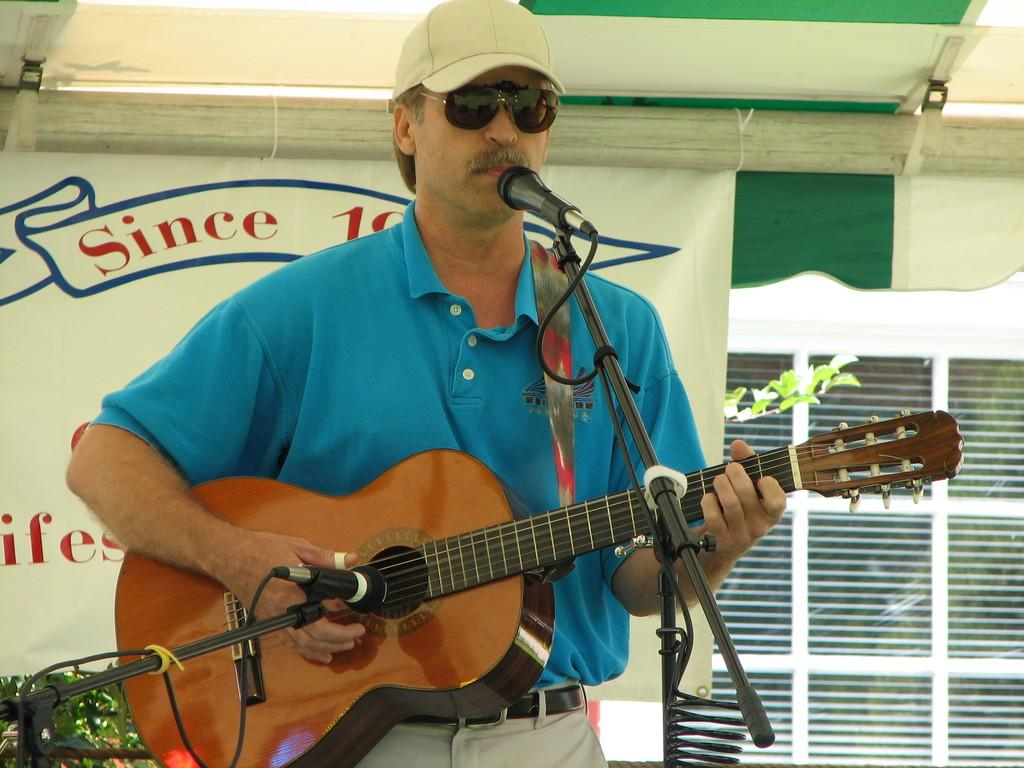What is the man in the image doing? There is a man standing in the image, but his activity is not specified. What musical instrument is present in the image? There is a guitar in the image. What device is used for amplifying sound in the image? There is a microphone in the image. What type of vegetation can be seen in the image? There are leaves in the image. What is hanging on the wall in the image? There is a poster in the image. What type of lunch is being served in the image? There is no lunch present in the image. How many rings can be seen on the man's fingers in the image? There is no mention of rings or fingers in the image. What type of beverage is being consumed in the image? There is no beverage present in the image. 